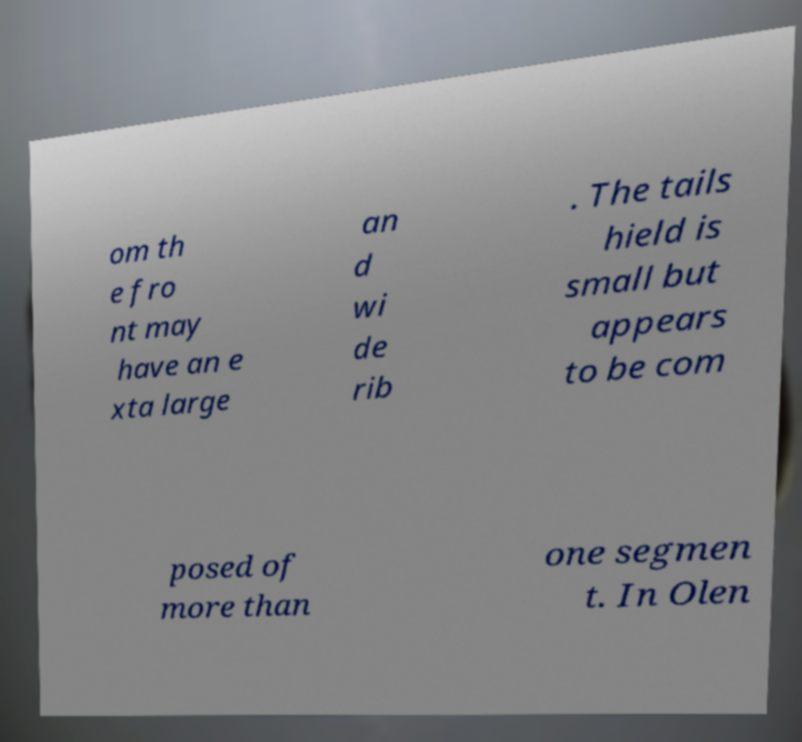Can you accurately transcribe the text from the provided image for me? om th e fro nt may have an e xta large an d wi de rib . The tails hield is small but appears to be com posed of more than one segmen t. In Olen 